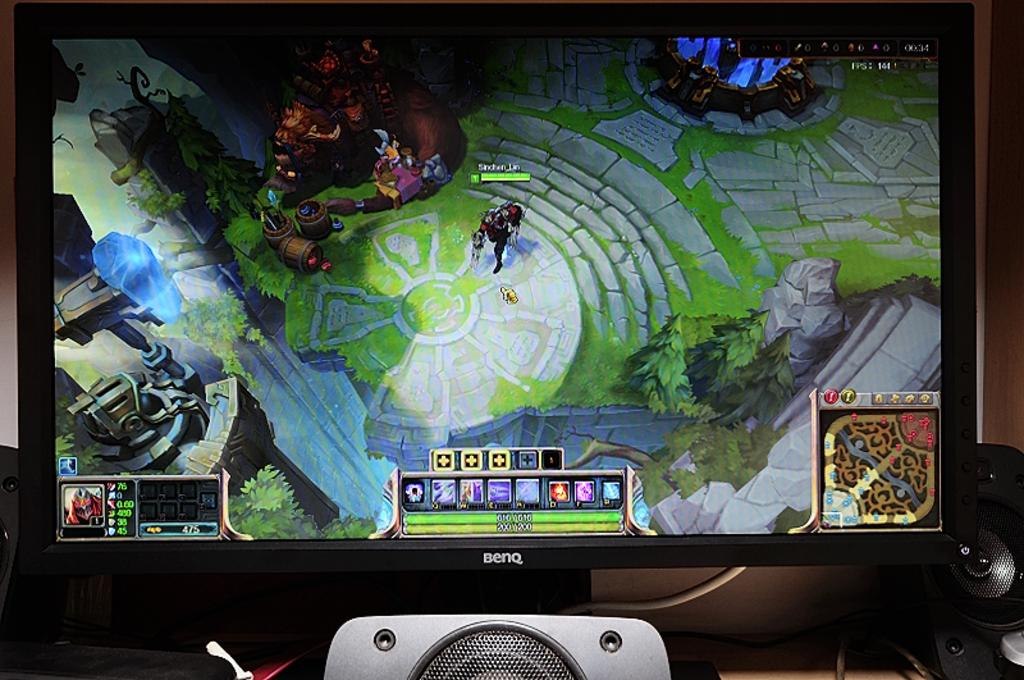What electronic device is present in the image? There is a television in the image. How is the television connected to other devices? There is a cable connected to the television. What are the audio components in the image? There are speakers in the image. What is being displayed on the television screen? A graphical image is displayed on the television screen. What can be seen in the background of the image? There is a wall in the background of the image. How many snails are crawling on the television in the image? There are no snails present in the image; it only features a television, a cable, speakers, a graphical image on the screen, and a wall in the background. 